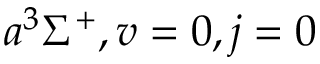<formula> <loc_0><loc_0><loc_500><loc_500>a ^ { 3 } \Sigma ^ { + } , v = 0 , j = 0</formula> 